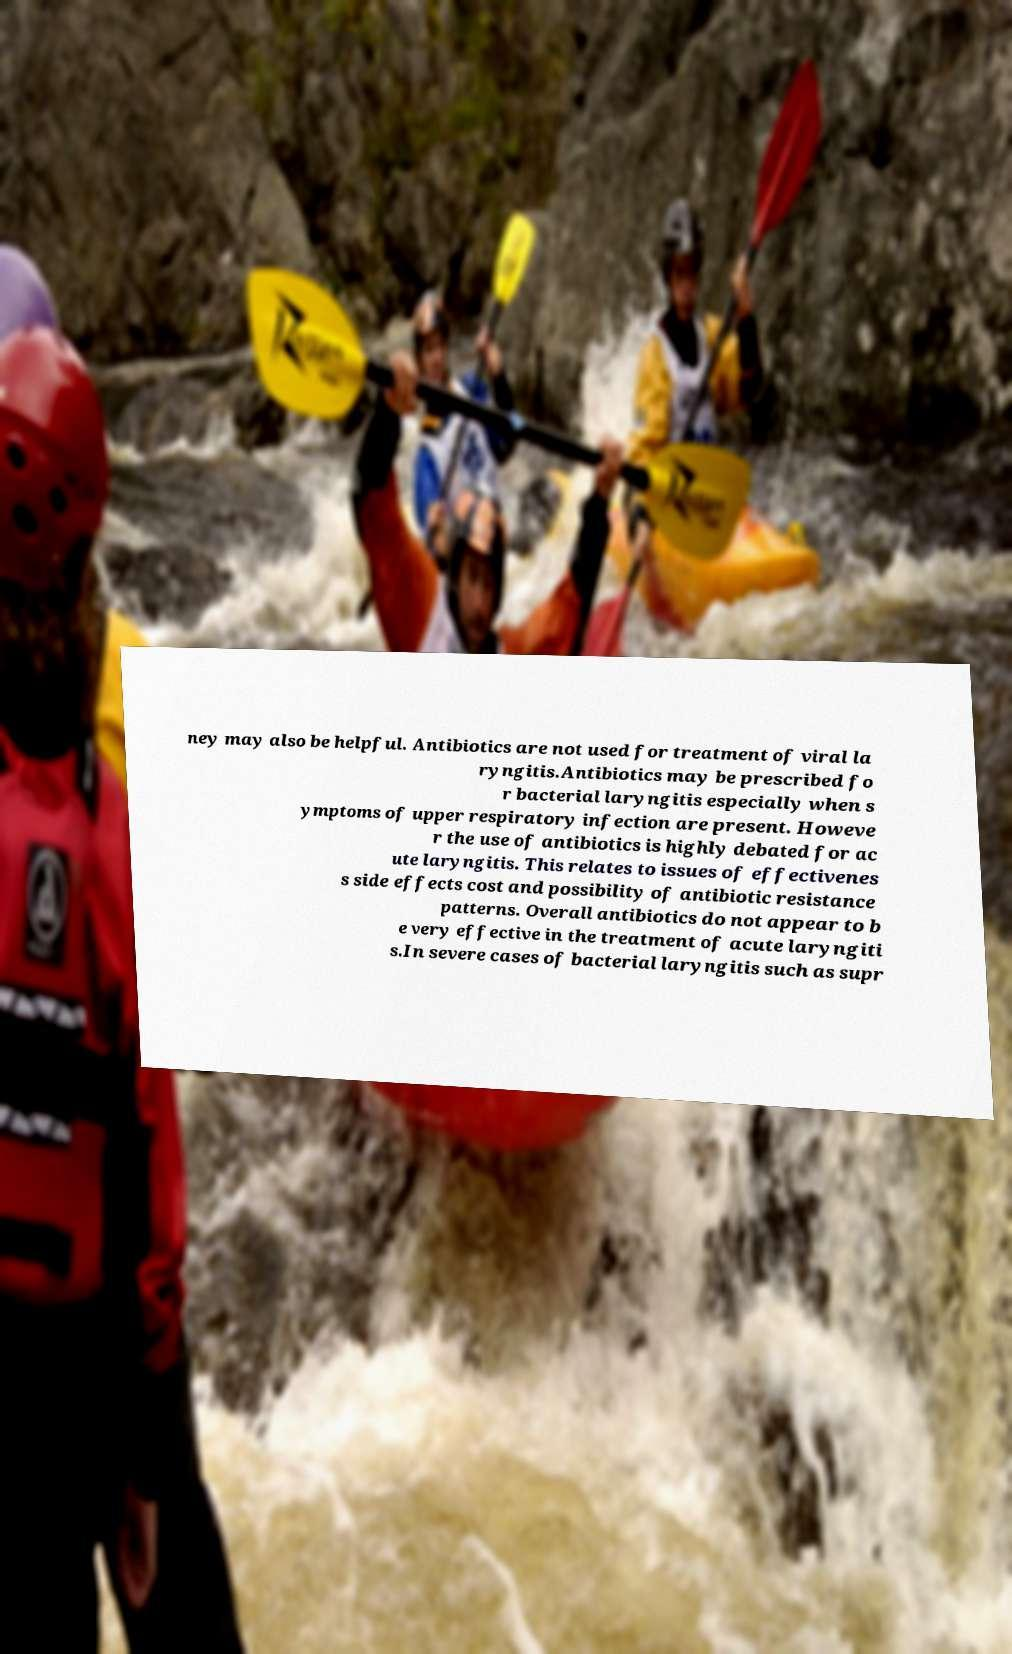Could you extract and type out the text from this image? ney may also be helpful. Antibiotics are not used for treatment of viral la ryngitis.Antibiotics may be prescribed fo r bacterial laryngitis especially when s ymptoms of upper respiratory infection are present. Howeve r the use of antibiotics is highly debated for ac ute laryngitis. This relates to issues of effectivenes s side effects cost and possibility of antibiotic resistance patterns. Overall antibiotics do not appear to b e very effective in the treatment of acute laryngiti s.In severe cases of bacterial laryngitis such as supr 